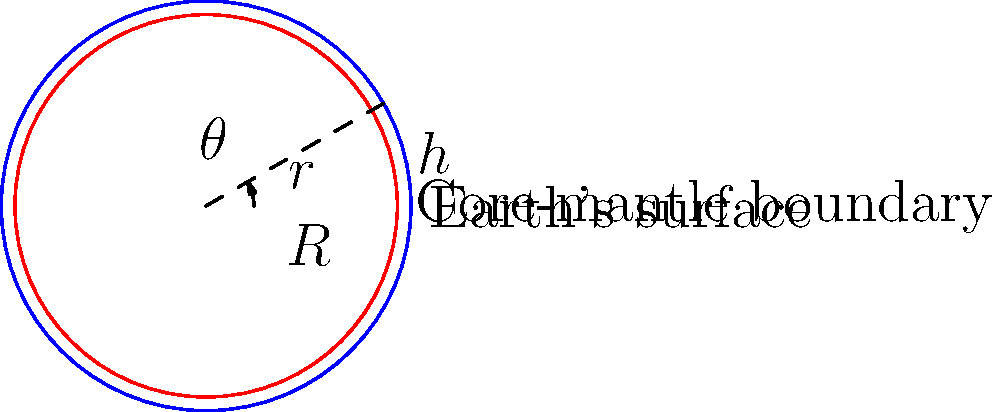Consider a simplified model of the Earth where the radius to the surface is $R = 6371$ km and the radius to the core-mantle boundary is $r = 3480$ km. If we measure an arc length of 1000 km along the core-mantle boundary, what is the central angle $\theta$ (in degrees) subtended by this arc? How does this compare to the angle subtended by the same arc length on the Earth's surface? Let's approach this step-by-step:

1) First, recall the formula for arc length: $s = r\theta$, where $s$ is the arc length, $r$ is the radius, and $\theta$ is the angle in radians.

2) For the core-mantle boundary:
   $1000 = 3480\theta$
   $\theta = \frac{1000}{3480} \approx 0.2874$ radians

3) Convert this to degrees:
   $\theta_{degrees} = 0.2874 \times \frac{180}{\pi} \approx 16.47°$

4) Now, for the Earth's surface:
   $1000 = 6371\theta$
   $\theta = \frac{1000}{6371} \approx 0.1569$ radians
   $\theta_{degrees} = 0.1569 \times \frac{180}{\pi} \approx 8.99°$

5) The ratio of these angles is:
   $\frac{16.47°}{8.99°} \approx 1.83$

This means the angle subtended at the core-mantle boundary is about 1.83 times larger than the angle subtended at the Earth's surface for the same arc length.
Answer: $16.47°$; 1.83 times larger than at the surface 